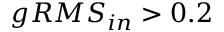<formula> <loc_0><loc_0><loc_500><loc_500>g R M S _ { i n } > 0 . 2</formula> 